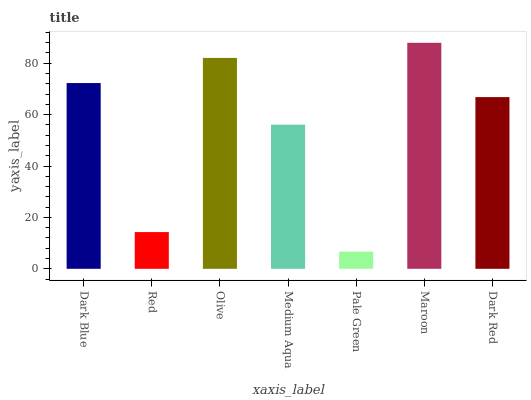Is Pale Green the minimum?
Answer yes or no. Yes. Is Maroon the maximum?
Answer yes or no. Yes. Is Red the minimum?
Answer yes or no. No. Is Red the maximum?
Answer yes or no. No. Is Dark Blue greater than Red?
Answer yes or no. Yes. Is Red less than Dark Blue?
Answer yes or no. Yes. Is Red greater than Dark Blue?
Answer yes or no. No. Is Dark Blue less than Red?
Answer yes or no. No. Is Dark Red the high median?
Answer yes or no. Yes. Is Dark Red the low median?
Answer yes or no. Yes. Is Pale Green the high median?
Answer yes or no. No. Is Olive the low median?
Answer yes or no. No. 